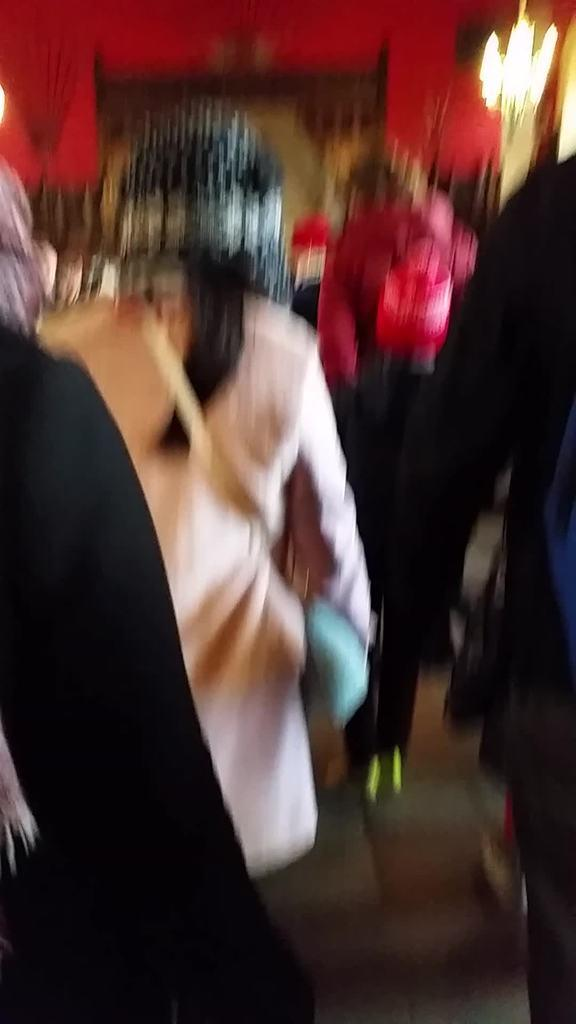Who or what can be seen in the image? There are people in the image. What is the color of the wall in the image? There is a red color wall in the image. What can be seen illuminating the scene in the image? There are lights in the image. How would you describe the clarity of the image? The image is blurred. What type of cabbage is being used as a crayon in the image? There is no cabbage or crayon present in the image. 